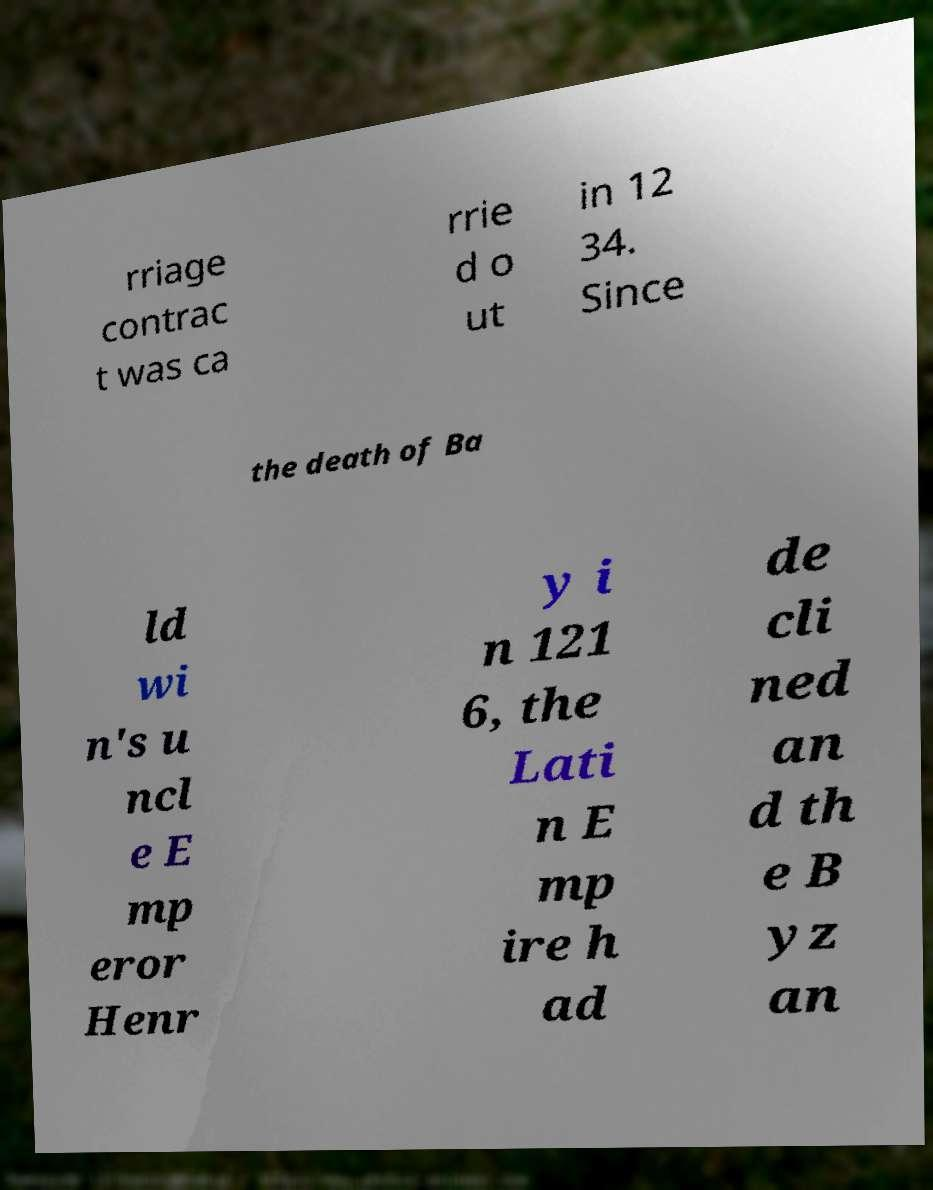Could you extract and type out the text from this image? rriage contrac t was ca rrie d o ut in 12 34. Since the death of Ba ld wi n's u ncl e E mp eror Henr y i n 121 6, the Lati n E mp ire h ad de cli ned an d th e B yz an 